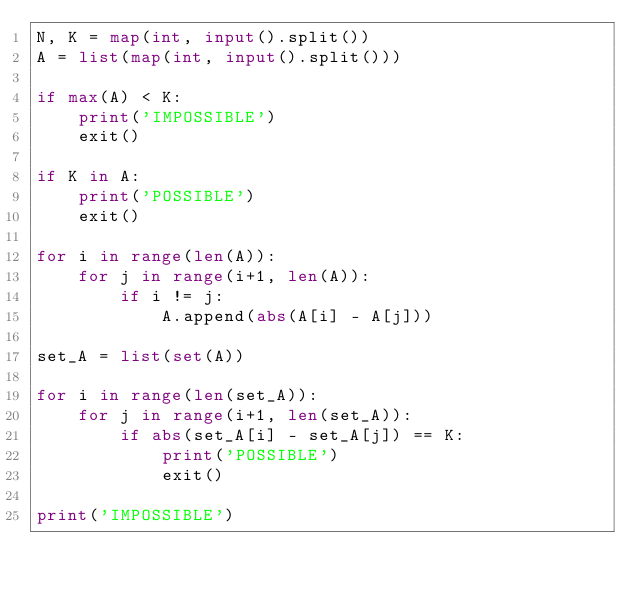<code> <loc_0><loc_0><loc_500><loc_500><_Python_>N, K = map(int, input().split())
A = list(map(int, input().split()))

if max(A) < K:
    print('IMPOSSIBLE')
    exit()

if K in A:
    print('POSSIBLE')
    exit()

for i in range(len(A)):
    for j in range(i+1, len(A)):
        if i != j:
            A.append(abs(A[i] - A[j]))

set_A = list(set(A))

for i in range(len(set_A)):
    for j in range(i+1, len(set_A)):
        if abs(set_A[i] - set_A[j]) == K:
            print('POSSIBLE')
            exit()

print('IMPOSSIBLE')</code> 